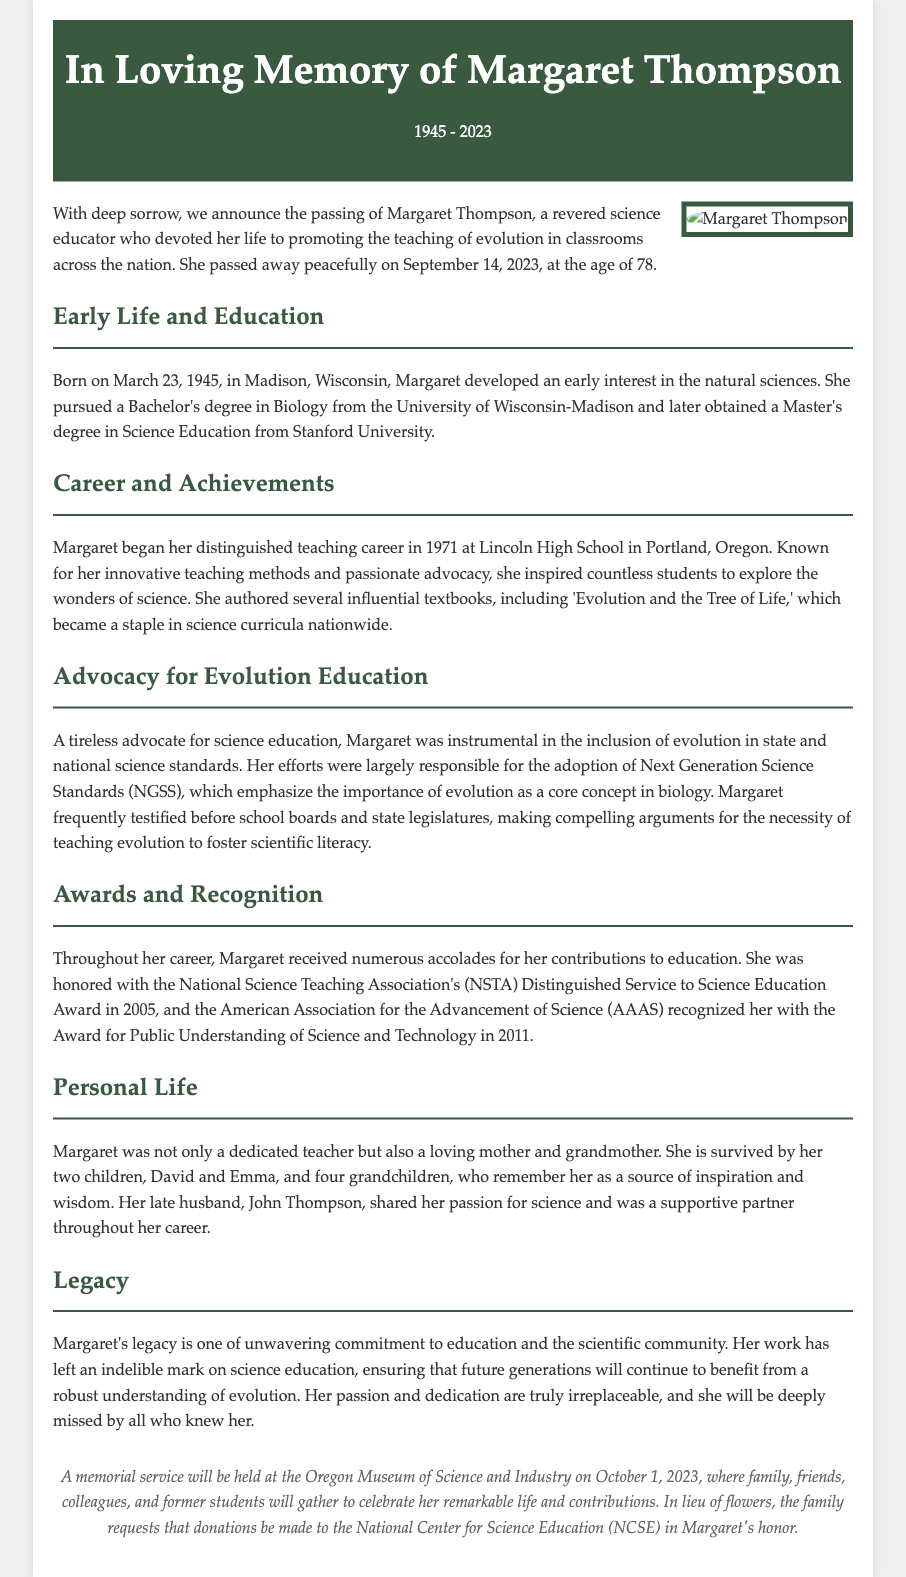What date did Margaret Thompson pass away? The document states that she passed away on September 14, 2023.
Answer: September 14, 2023 What degree did Margaret Thompson obtain from Stanford University? The document mentions that she obtained a Master's degree in Science Education from Stanford University.
Answer: Master's degree in Science Education What notable textbook did Margaret author? The document lists "Evolution and the Tree of Life" as a textbook authored by Margaret.
Answer: Evolution and the Tree of Life In what year did Margaret receive the NSTA's Distinguished Service to Science Education Award? The document specifies that she received the award in 2005.
Answer: 2005 How many grandchildren did Margaret have? The document states that she is survived by four grandchildren.
Answer: Four What was Margaret's role in relation to state and national science standards? The document describes her as being instrumental in the inclusion of evolution in state and national science standards.
Answer: Instrumental in the inclusion of evolution Where will the memorial service for Margaret be held? The document indicates that the memorial service will be held at the Oregon Museum of Science and Industry.
Answer: Oregon Museum of Science and Industry What year was Margaret born? The document states that she was born on March 23, 1945.
Answer: 1945 